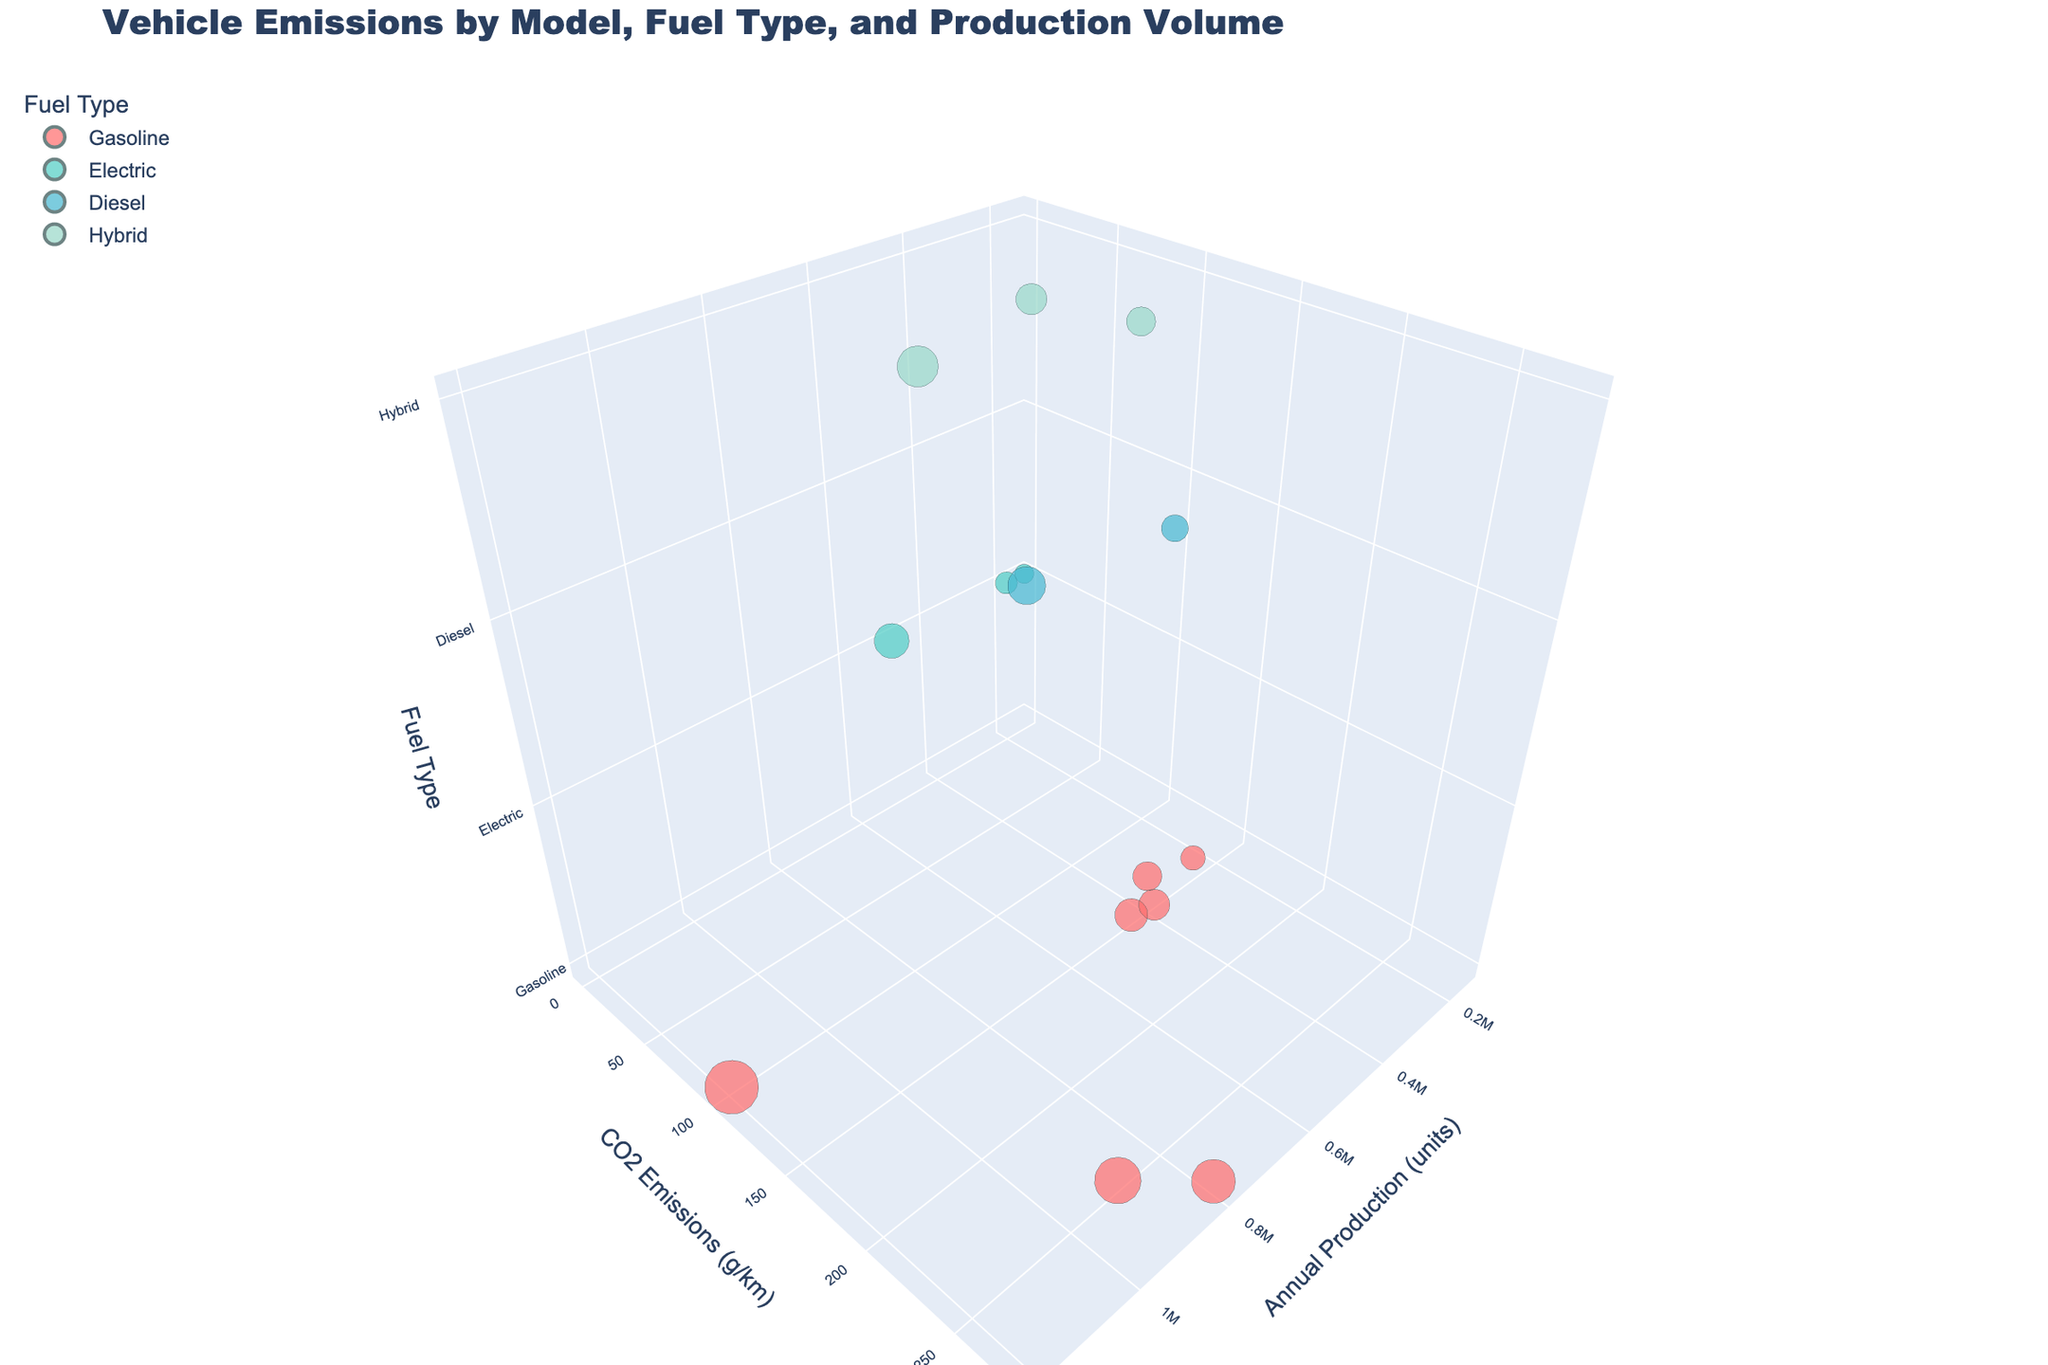What is the title of the chart? The title is displayed at the top of the graph, indicating the main subject of the data being visualized. The text directly mentions the topics and variables included in the visualization.
Answer: Vehicle Emissions by Model, Fuel Type, and Production Volume How many models use electric fuel? Each data point represents a model and its fuel type. By checking the color (typically green for electric) and the labels provided in the legend, you can count the electric models.
Answer: 3 Which model has the highest CO2 emissions, and what are they? By examining the y-axis (CO2 Emissions (g/km)) and identifying the highest point, you can find the model with the highest CO2 emissions and then look at the model name in the hover info.
Answer: Chevrolet Silverado, 277 g/km What is the total annual production of hybrid models? To find this, sum the sizes (Annual Production) of all data points colored to represent hybrid models.
Answer: 1,450,000 units Which fuel type has the largest bubble size overall, indicating the highest annual production volume collectively? The size of the bubbles represents the annual production volume. By summarizing the bubble sizes for each fuel type, you determine which is the largest.
Answer: Gasoline How do the CO2 emissions of electric models compare to other fuel types? By looking at the y-axis values for electric models (often at the bottom, indicating 0 CO2 emissions) and comparing them with gasoline, diesel, and hybrid models higher on the y-axis. Electric models have 0 emissions.
Answer: Electric models have 0 CO2 emissions Among the diesels, which model has the lowest CO2 emissions? Browse through the points representing diesel fuel type (typically blue) and find the point with the lowest y-axis value for CO2 emissions.
Answer: Volkswagen Golf, 120 g/km How does the annual production of Tesla Model 3 compare to Toyota Corolla? Find the bubble corresponding to each model and compare their positions along the x-axis (Annual Production (units)). Tesla Model 3 has lower production than Toyota Corolla.
Answer: Tesla Model 3 is lower On average, which produces less CO2 emissions: hybrid or gasoline models? Calculate the average CO2 emissions for hybrid models by summing their CO2 emissions and dividing by the number of hybrid models. Do the same for gasoline models and compare the results. Average of hybrid: (89 + 70 + 118)/3, Average of gasoline: (103 + 250 + 138 + 277 + 151 + 145 + 154)/7.
Answer: Hybrid models produce less CO2 emissions 